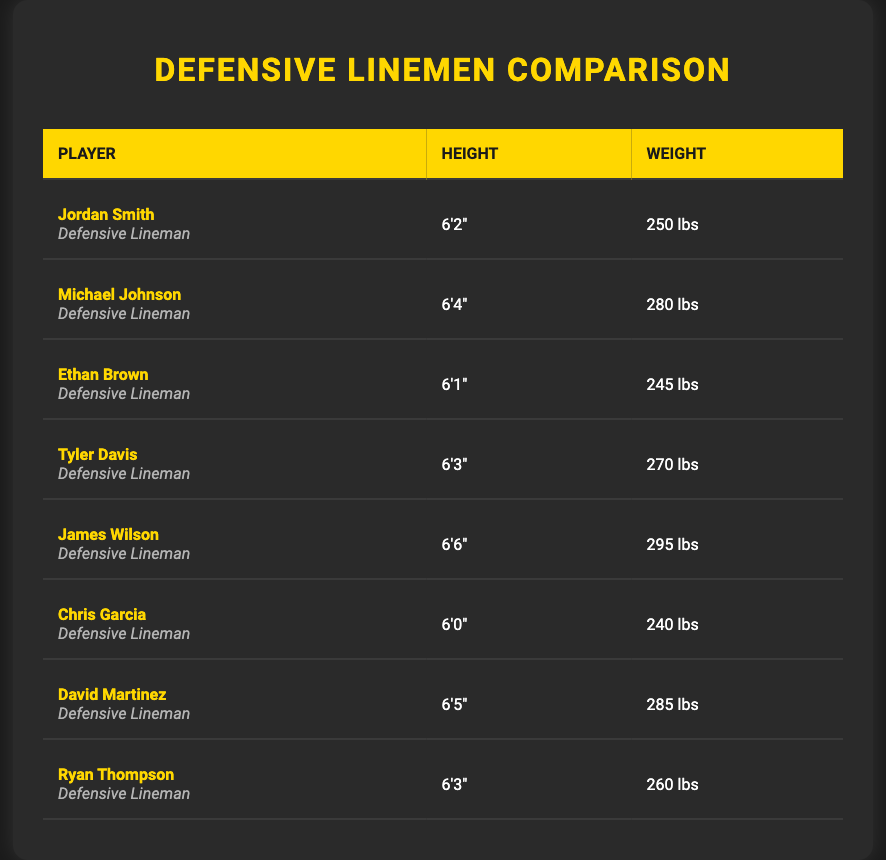What is the height of James Wilson? Referring to the table in the "Height" column and locating James Wilson's row shows that his height is listed as 6'6".
Answer: 6'6" Who has the highest weight among these players? By reviewing the "Weight" column, James Wilson has the highest weight at 295 lbs, which is greater than all other players.
Answer: 295 lbs What's the average weight of all the players listed? To find the average weight, add all the weights: 250 + 280 + 245 + 270 + 295 + 240 + 285 + 260 = 2265 lbs. Then divide by the number of players (8): 2265 / 8 = 283.125 lbs.
Answer: 283.125 lbs Is Chris Garcia the lightest player on the list? Comparing the weights, Chris Garcia's weight is 240 lbs. Checking all other weights, he is lighter than all other players, confirming he is indeed the lightest player.
Answer: Yes How many players weigh over 260 lbs? Looking through the "Weight" column, the players weighing over 260 lbs are Michael Johnson (280 lbs), Tyler Davis (270 lbs), James Wilson (295 lbs), and David Martinez (285 lbs), totaling four players.
Answer: 4 players Which player has the closest height to 6'3"? Checking the "Height" column, both Tyler Davis and Ryan Thompson have heights listed as 6'3", making them the closest to 6'3".
Answer: Tyler Davis and Ryan Thompson What is the difference in height between the tallest and shortest players? Identifying from the table, James Wilson is the tallest at 6'6", and Chris Garcia is the shortest at 6'0". The height difference is calculated as 6'6" minus 6'0", which results in 6 inches.
Answer: 6 inches Are there more players listed weighing over 250 lbs or under? Players weighing over 250 lbs are Michael Johnson (280 lbs), James Wilson (295 lbs), and David Martinez (285 lbs). Players weighing under 250 lbs are Ethan Brown (245 lbs) and Chris Garcia (240 lbs). Thus, there are three players over 250 lbs and two under, indicating more players over 250 lbs.
Answer: More players weigh over 250 lbs 